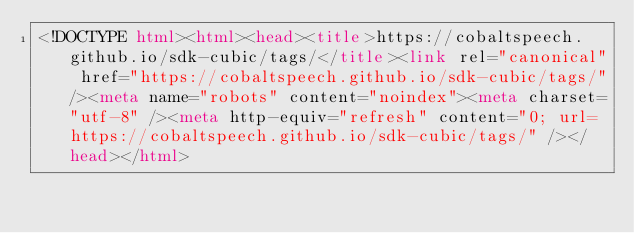<code> <loc_0><loc_0><loc_500><loc_500><_HTML_><!DOCTYPE html><html><head><title>https://cobaltspeech.github.io/sdk-cubic/tags/</title><link rel="canonical" href="https://cobaltspeech.github.io/sdk-cubic/tags/"/><meta name="robots" content="noindex"><meta charset="utf-8" /><meta http-equiv="refresh" content="0; url=https://cobaltspeech.github.io/sdk-cubic/tags/" /></head></html></code> 